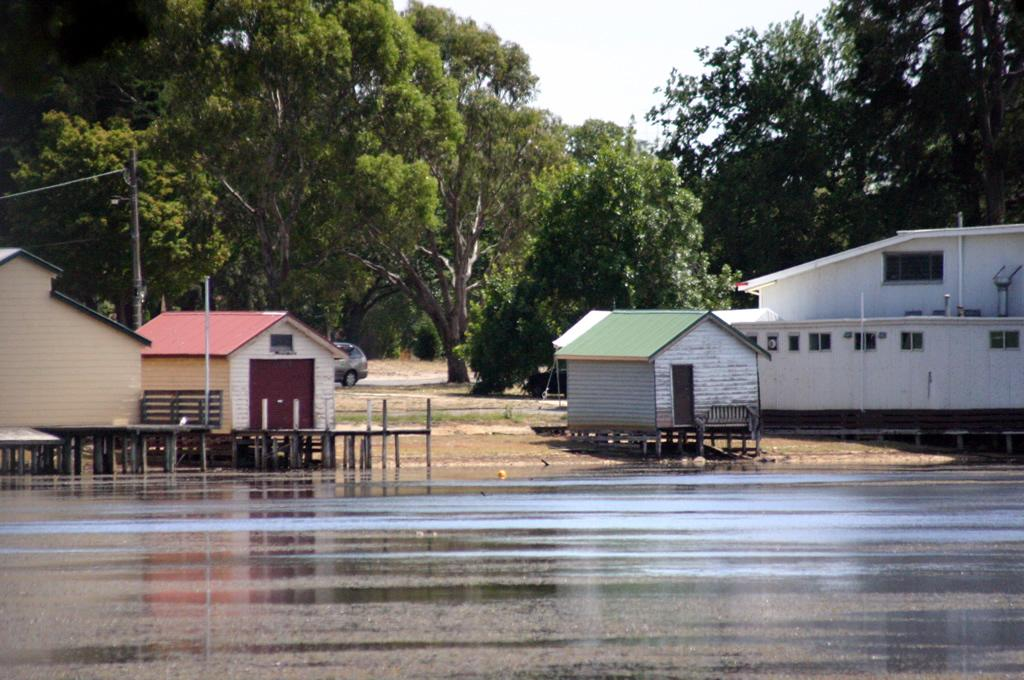What is located in the center of the image? There are houses and buildings in the center of the image. What is at the bottom of the image? There is water at the bottom of the image. What can be seen in the background of the image? There is a road, a vehicle, a pole, trees, and the sky visible in the background of the image. How many rabbits are hopping around in the water at the bottom of the image? There are no rabbits present in the image; it features water at the bottom. What type of blade is attached to the pole in the background of the image? There is no blade present in the image; only a pole is visible in the background. 